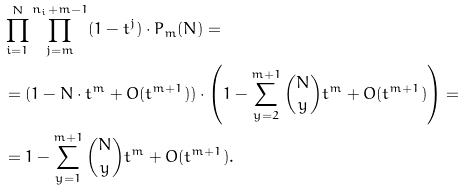<formula> <loc_0><loc_0><loc_500><loc_500>& \prod _ { i = 1 } ^ { N } \prod _ { j = m } ^ { n _ { i } + m - 1 } ( 1 - t ^ { j } ) \cdot P _ { m } ( N ) = \\ & = ( 1 - N \cdot t ^ { m } + O ( t ^ { m + 1 } ) ) \cdot \left ( 1 - \sum _ { y = 2 } ^ { m + 1 } \binom { N } { y } t ^ { m } + O ( t ^ { m + 1 } ) \right ) = \\ & = 1 - \sum _ { y = 1 } ^ { m + 1 } \binom { N } { y } t ^ { m } + O ( t ^ { m + 1 } ) .</formula> 